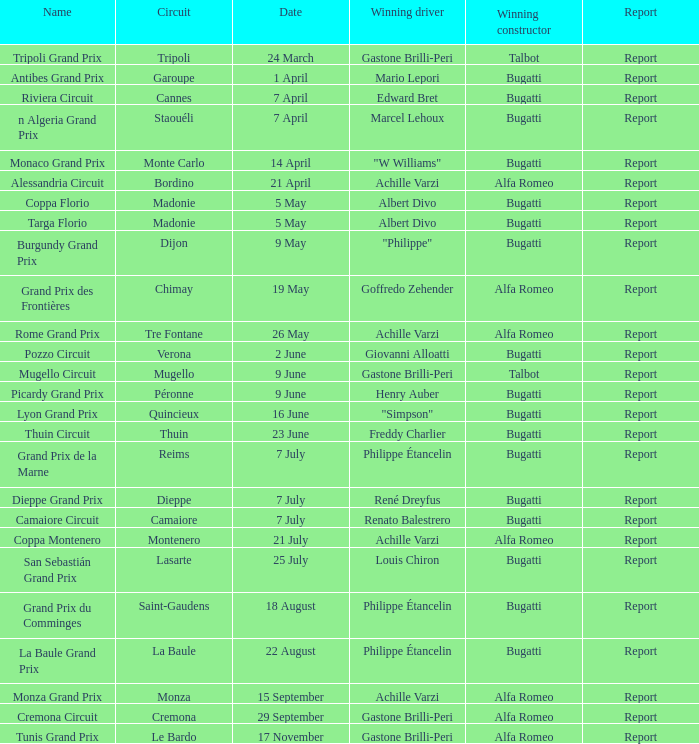What Name has a Winning constructor of bugatti, and a Winning driver of louis chiron? San Sebastián Grand Prix. 